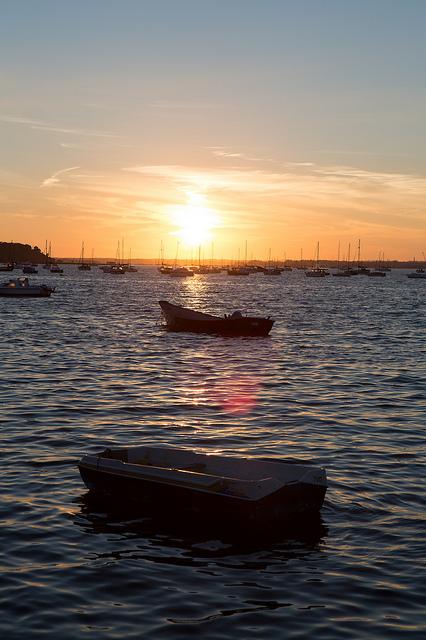What reflection can be seen in the water?
Write a very short answer. Sun. How tall is the wave?
Give a very brief answer. Small. How many boats are visible?
Answer briefly. 20. What is at the front of the photo?
Write a very short answer. Boat. How many fishing poles is there?
Quick response, please. 0. Is the water placid?
Be succinct. Yes. How many people would be on this boat?
Be succinct. 2. How many small waves are in the lake?
Keep it brief. 1000. What color stands out?
Give a very brief answer. Orange. Are any of the sailboats using their sails?
Quick response, please. No. Is there a boat in the foreground?
Write a very short answer. Yes. What time of day is it?
Keep it brief. Sunset. What type of boat is this?
Short answer required. Row. Are there any people on the boat?
Write a very short answer. No. How many people is on the boat?
Short answer required. 0. Is this a beach?
Keep it brief. No. What is the color of the sky?
Keep it brief. Blue. 